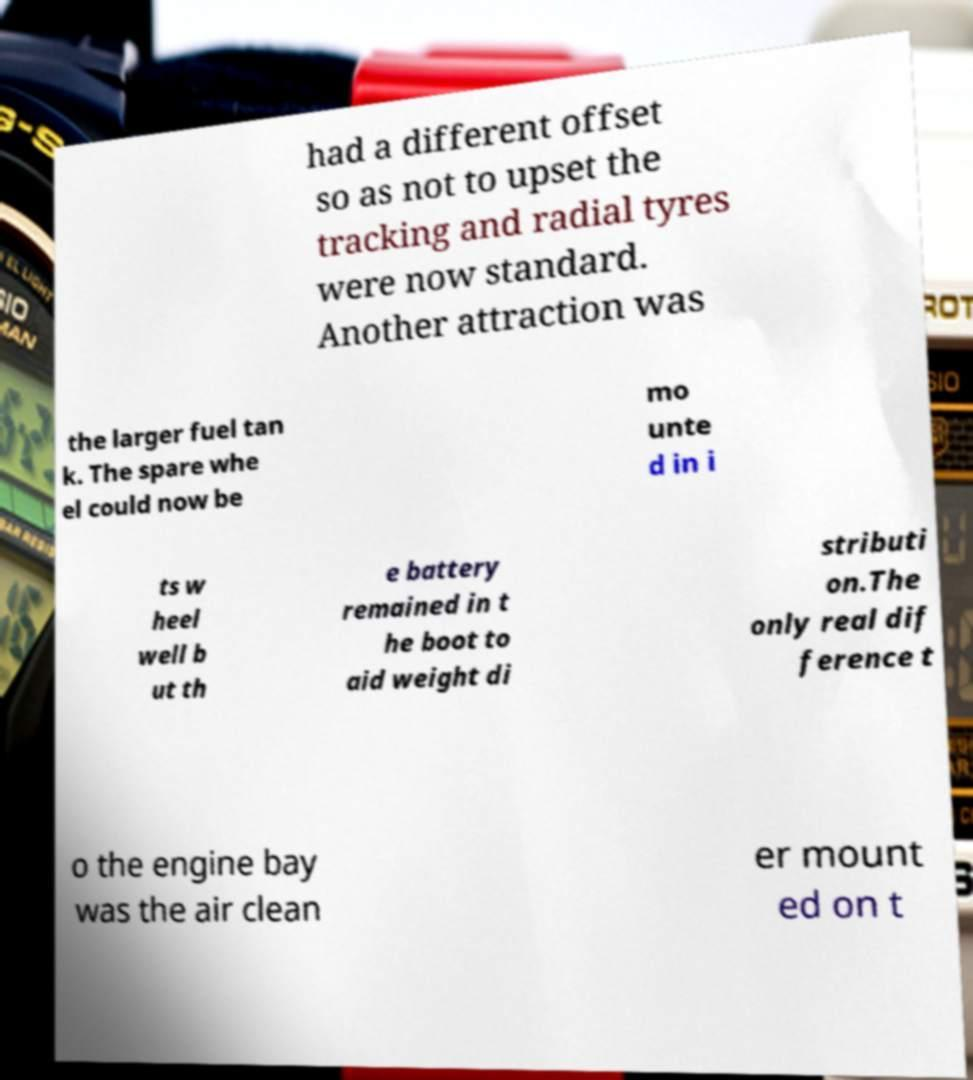I need the written content from this picture converted into text. Can you do that? had a different offset so as not to upset the tracking and radial tyres were now standard. Another attraction was the larger fuel tan k. The spare whe el could now be mo unte d in i ts w heel well b ut th e battery remained in t he boot to aid weight di stributi on.The only real dif ference t o the engine bay was the air clean er mount ed on t 